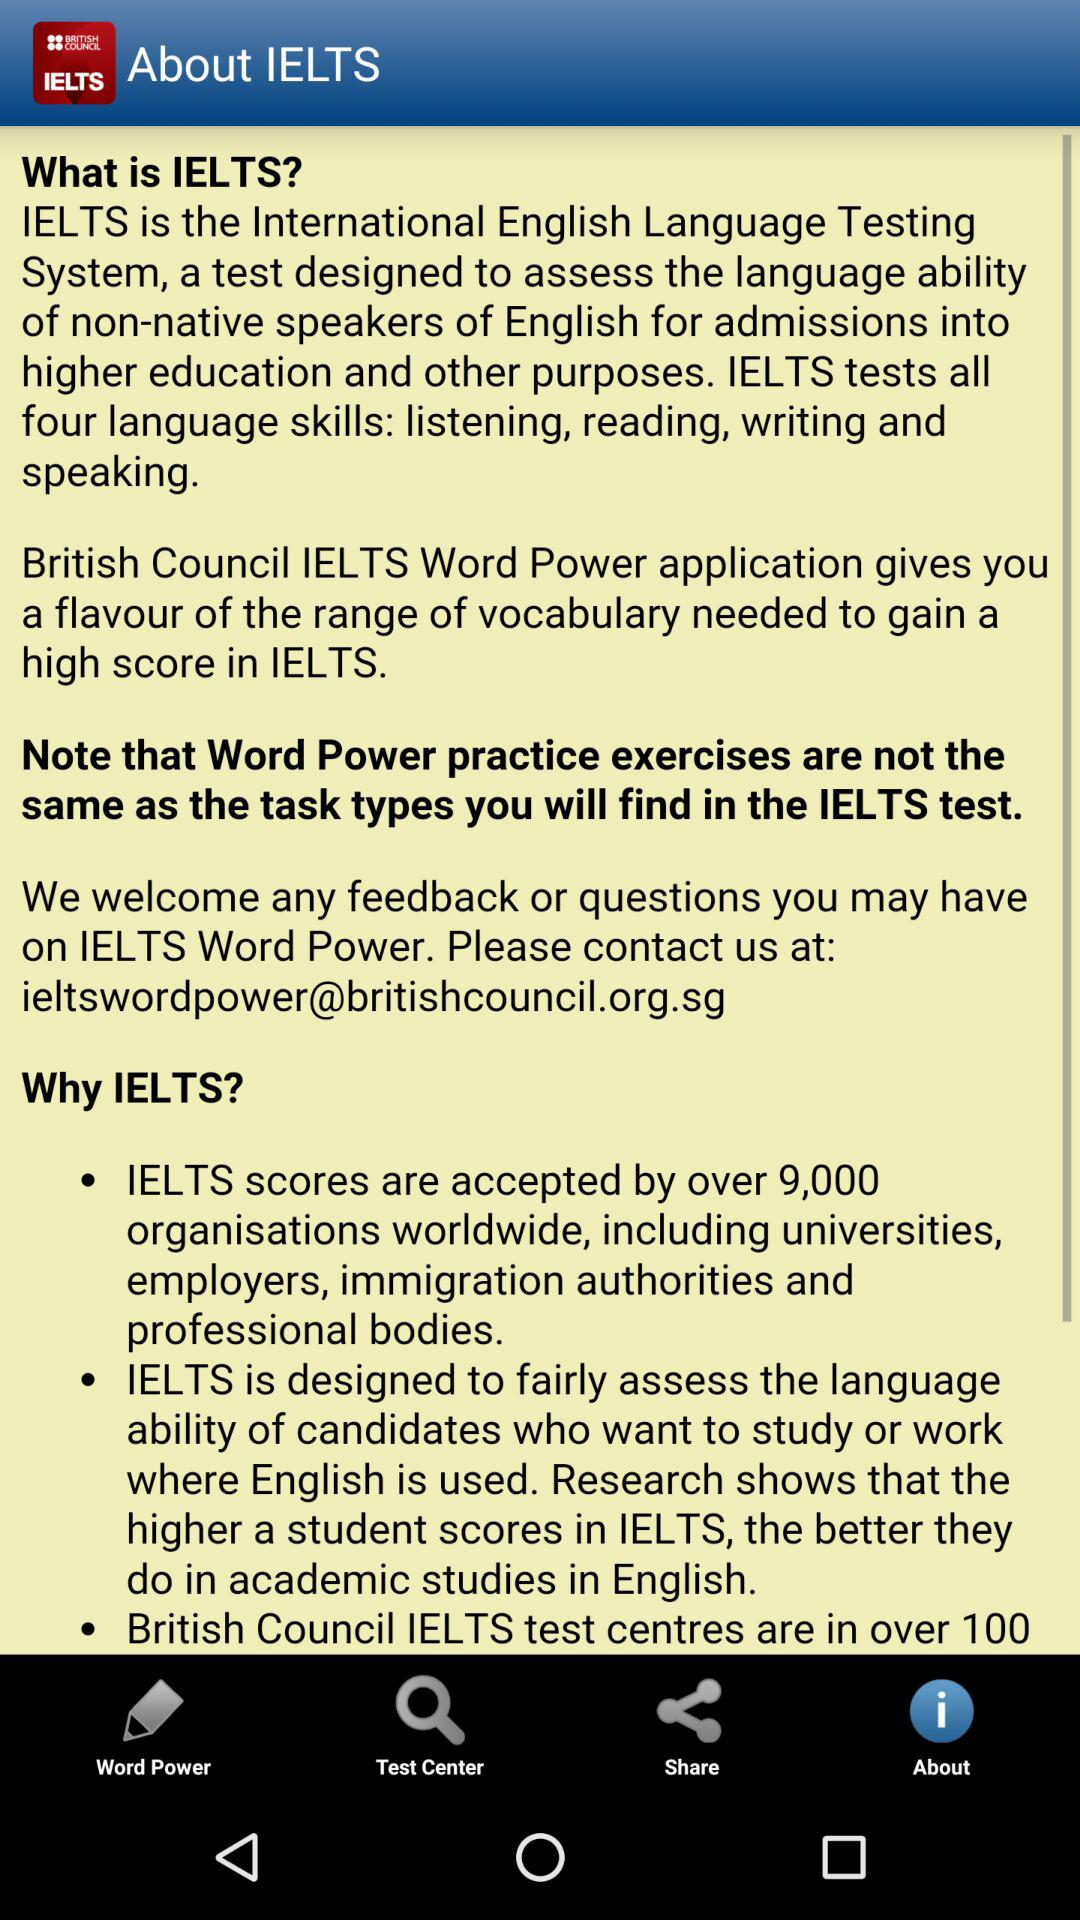What site is given for customer support? The site given for customer support is ieltswordpower@britishcouncil.org.sg. 